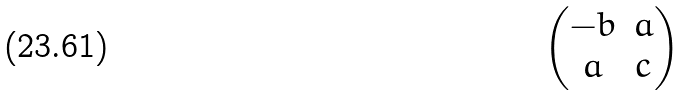Convert formula to latex. <formula><loc_0><loc_0><loc_500><loc_500>\begin{pmatrix} - b & a \\ a & c \end{pmatrix}</formula> 